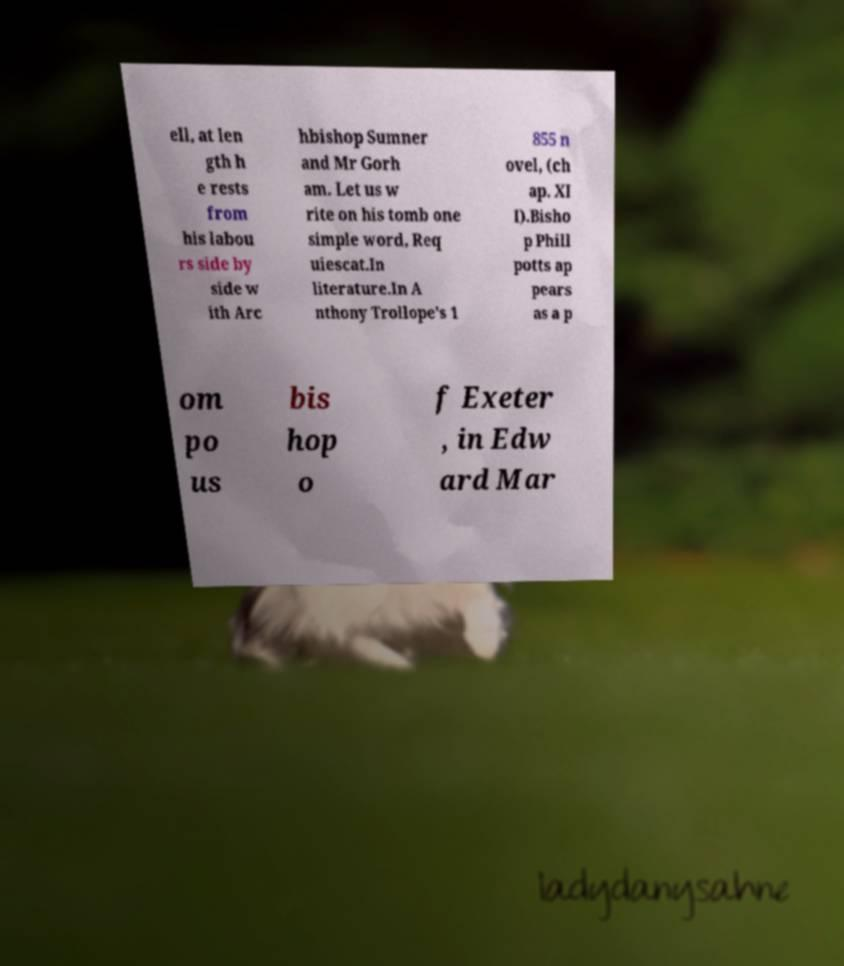Please read and relay the text visible in this image. What does it say? ell, at len gth h e rests from his labou rs side by side w ith Arc hbishop Sumner and Mr Gorh am. Let us w rite on his tomb one simple word, Req uiescat.In literature.In A nthony Trollope's 1 855 n ovel, (ch ap. XI I).Bisho p Phill potts ap pears as a p om po us bis hop o f Exeter , in Edw ard Mar 